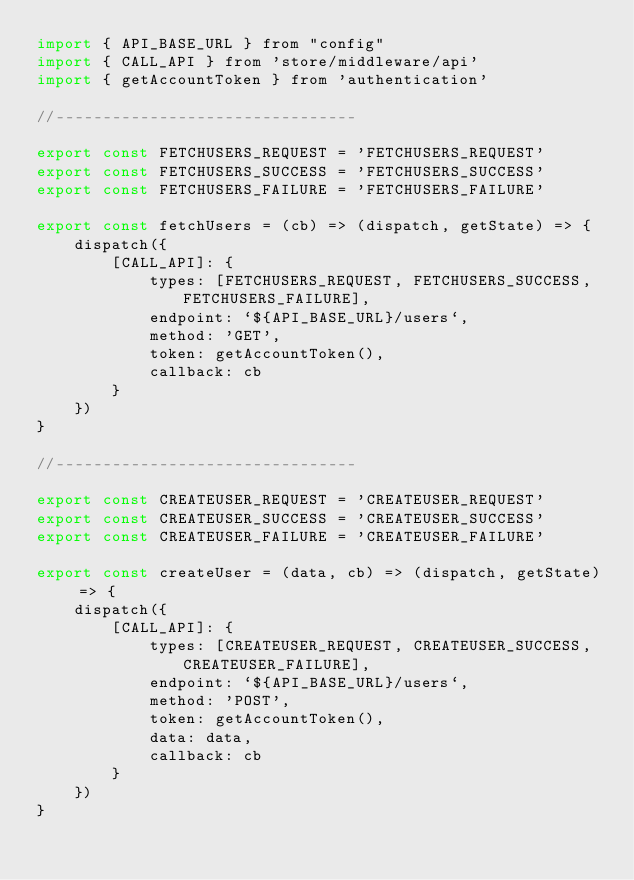Convert code to text. <code><loc_0><loc_0><loc_500><loc_500><_JavaScript_>import { API_BASE_URL } from "config"
import { CALL_API } from 'store/middleware/api'
import { getAccountToken } from 'authentication'

//--------------------------------

export const FETCHUSERS_REQUEST = 'FETCHUSERS_REQUEST'
export const FETCHUSERS_SUCCESS = 'FETCHUSERS_SUCCESS'
export const FETCHUSERS_FAILURE = 'FETCHUSERS_FAILURE'

export const fetchUsers = (cb) => (dispatch, getState) => {
    dispatch({
        [CALL_API]: {
            types: [FETCHUSERS_REQUEST, FETCHUSERS_SUCCESS, FETCHUSERS_FAILURE],
            endpoint: `${API_BASE_URL}/users`,
            method: 'GET',
            token: getAccountToken(),
            callback: cb
        }
    })
}

//--------------------------------

export const CREATEUSER_REQUEST = 'CREATEUSER_REQUEST'
export const CREATEUSER_SUCCESS = 'CREATEUSER_SUCCESS'
export const CREATEUSER_FAILURE = 'CREATEUSER_FAILURE'

export const createUser = (data, cb) => (dispatch, getState) => {
    dispatch({
        [CALL_API]: {
            types: [CREATEUSER_REQUEST, CREATEUSER_SUCCESS, CREATEUSER_FAILURE],
            endpoint: `${API_BASE_URL}/users`,
            method: 'POST',
            token: getAccountToken(),
            data: data,
            callback: cb
        }
    })
}
</code> 